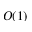Convert formula to latex. <formula><loc_0><loc_0><loc_500><loc_500>O ( 1 )</formula> 